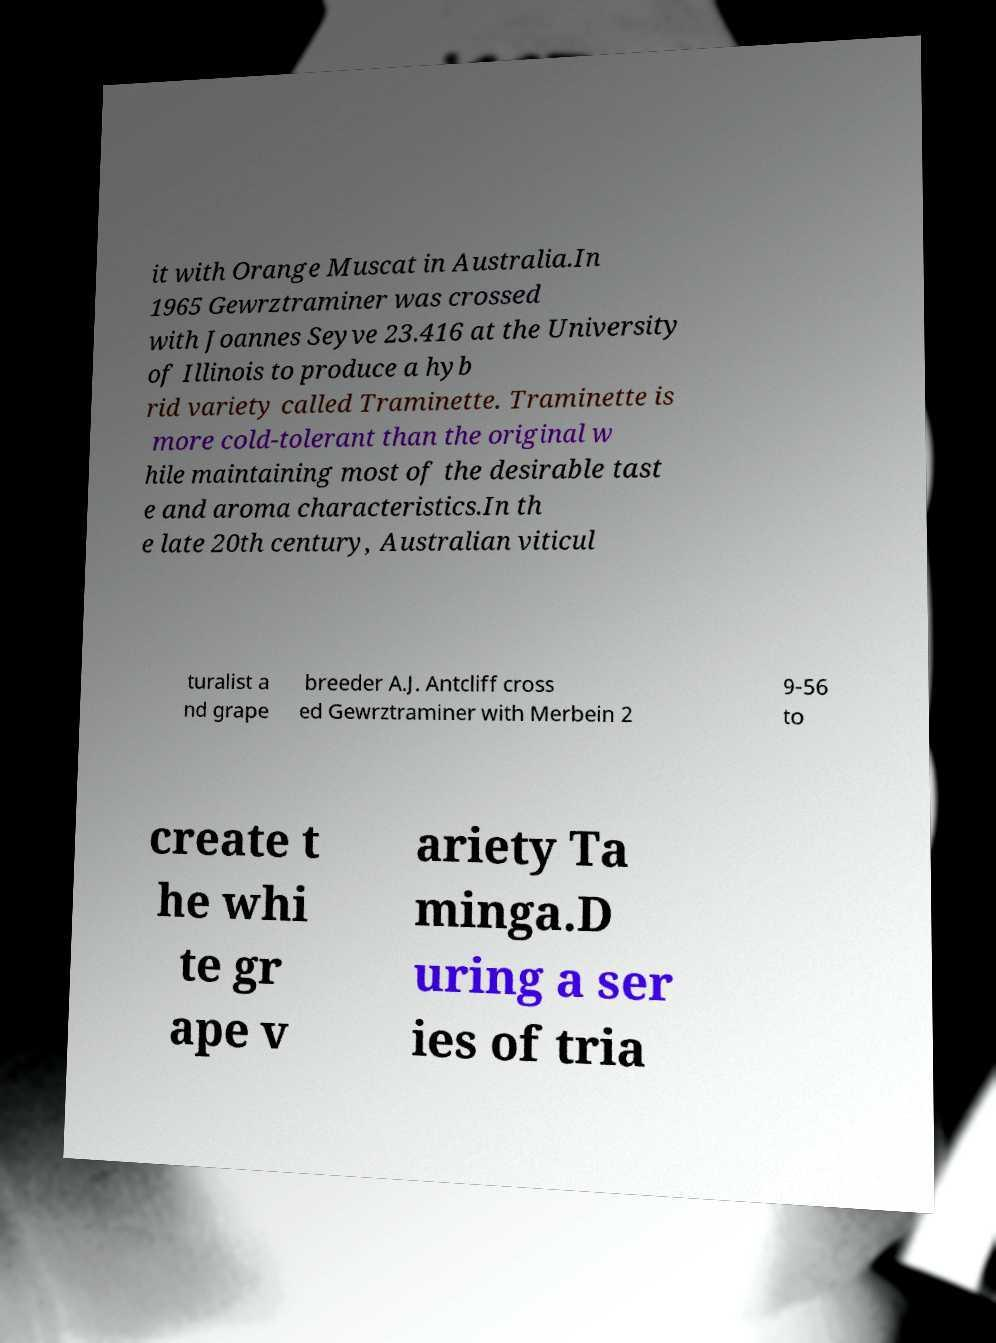Can you accurately transcribe the text from the provided image for me? it with Orange Muscat in Australia.In 1965 Gewrztraminer was crossed with Joannes Seyve 23.416 at the University of Illinois to produce a hyb rid variety called Traminette. Traminette is more cold-tolerant than the original w hile maintaining most of the desirable tast e and aroma characteristics.In th e late 20th century, Australian viticul turalist a nd grape breeder A.J. Antcliff cross ed Gewrztraminer with Merbein 2 9-56 to create t he whi te gr ape v ariety Ta minga.D uring a ser ies of tria 